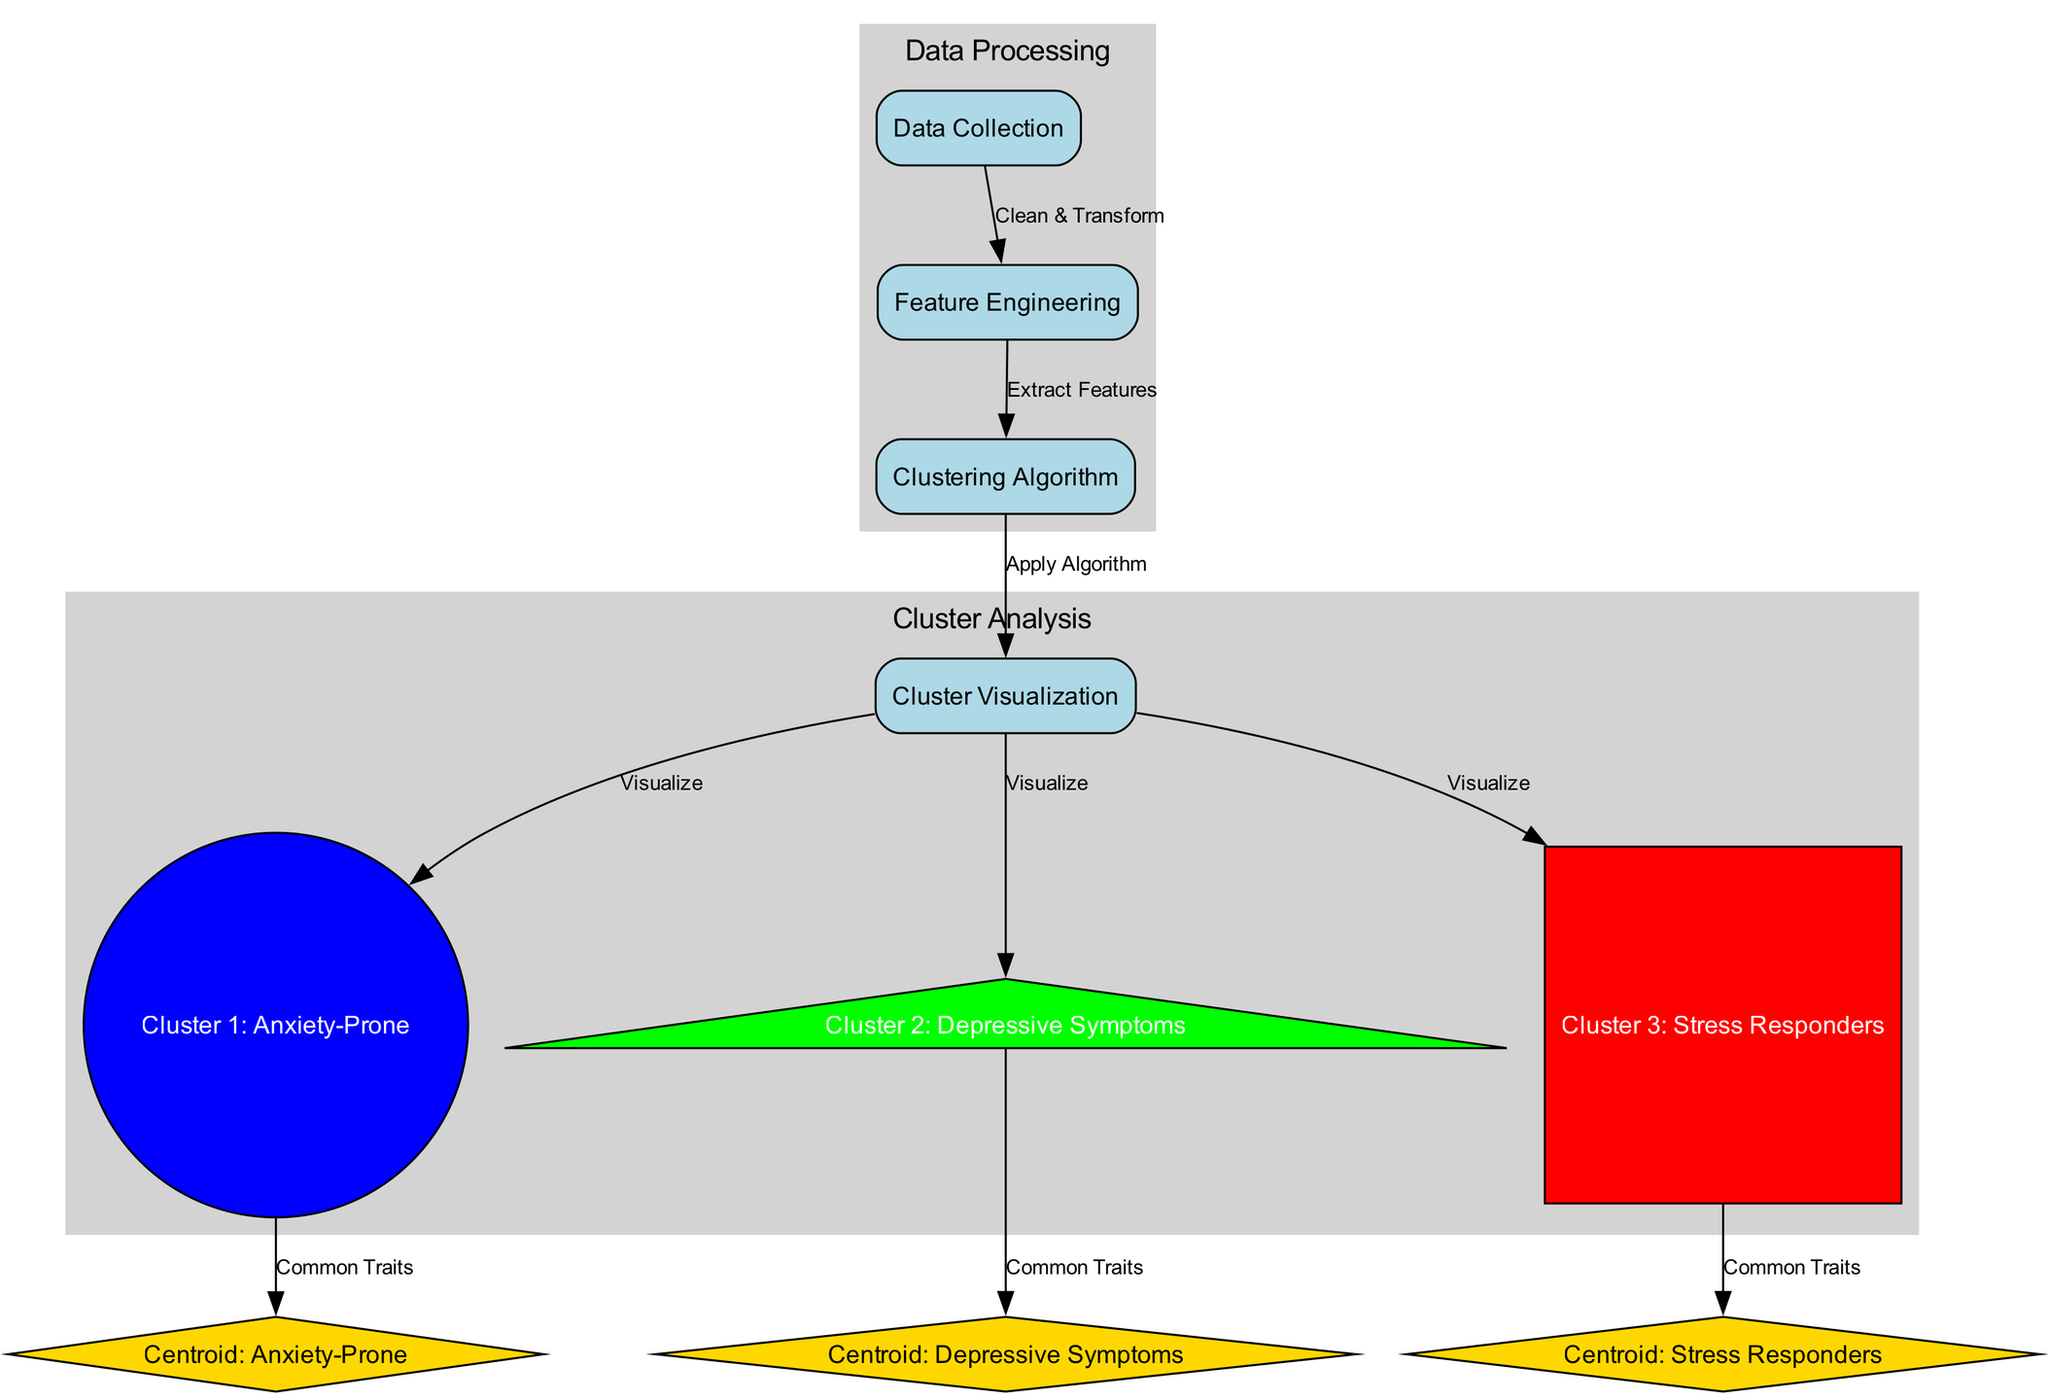What are the shapes used for the clusters? The diagram indicates that Cluster 1 is represented as a circle, Cluster 2 as a triangle, and Cluster 3 as a square.
Answer: Circle, Triangle, Square How many clusters are visualized in the diagram? There are three clusters visualized, namely Cluster 1, Cluster 2, and Cluster 3.
Answer: Three What is the label of the centroid for Cluster 2? The centroid for Cluster 2 is labeled as "Centroid: Depressive Symptoms." This label can be found by examining the centroid identified for that cluster.
Answer: Centroid: Depressive Symptoms What nodes come before the clustering algorithm? The nodes that come before the clustering algorithm are "Data Collection" and "Feature Engineering." These nodes are visually connected to the clustering algorithm through directed edges.
Answer: Data Collection, Feature Engineering Which color represents Cluster 3? Cluster 3 is represented by the color red, which can be identified directly in the diagram by observing the cluster's visual representation.
Answer: Red Why do we visualize the clusters after applying the clustering algorithm? The clusters are visualized after applying the clustering algorithm to illustrate the results of the algorithm on the processed data. Visualization aids in understanding how the data points are grouped based on their behavioral traits.
Answer: To illustrate groupings What process cleans and transforms the data? The process responsible for cleaning and transforming the data is labeled "Data Collection." This is evident as it is the starting point in the flow leading to the clustering algorithm.
Answer: Data Collection How many edges connect to Cluster Visualization? There are three edges connecting to Cluster Visualization, each leading to one of the clusters visualizing their respective characteristics.
Answer: Three Which nodes symbolize common traits for the clusters? The nodes that symbolize common traits for the clusters are "Centroid: Anxiety-Prone," "Centroid: Depressive Symptoms," and "Centroid: Stress Responders." These represent the commonalities identified in each cluster.
Answer: Centroid: Anxiety-Prone, Centroid: Depressive Symptoms, Centroid: Stress Responders 